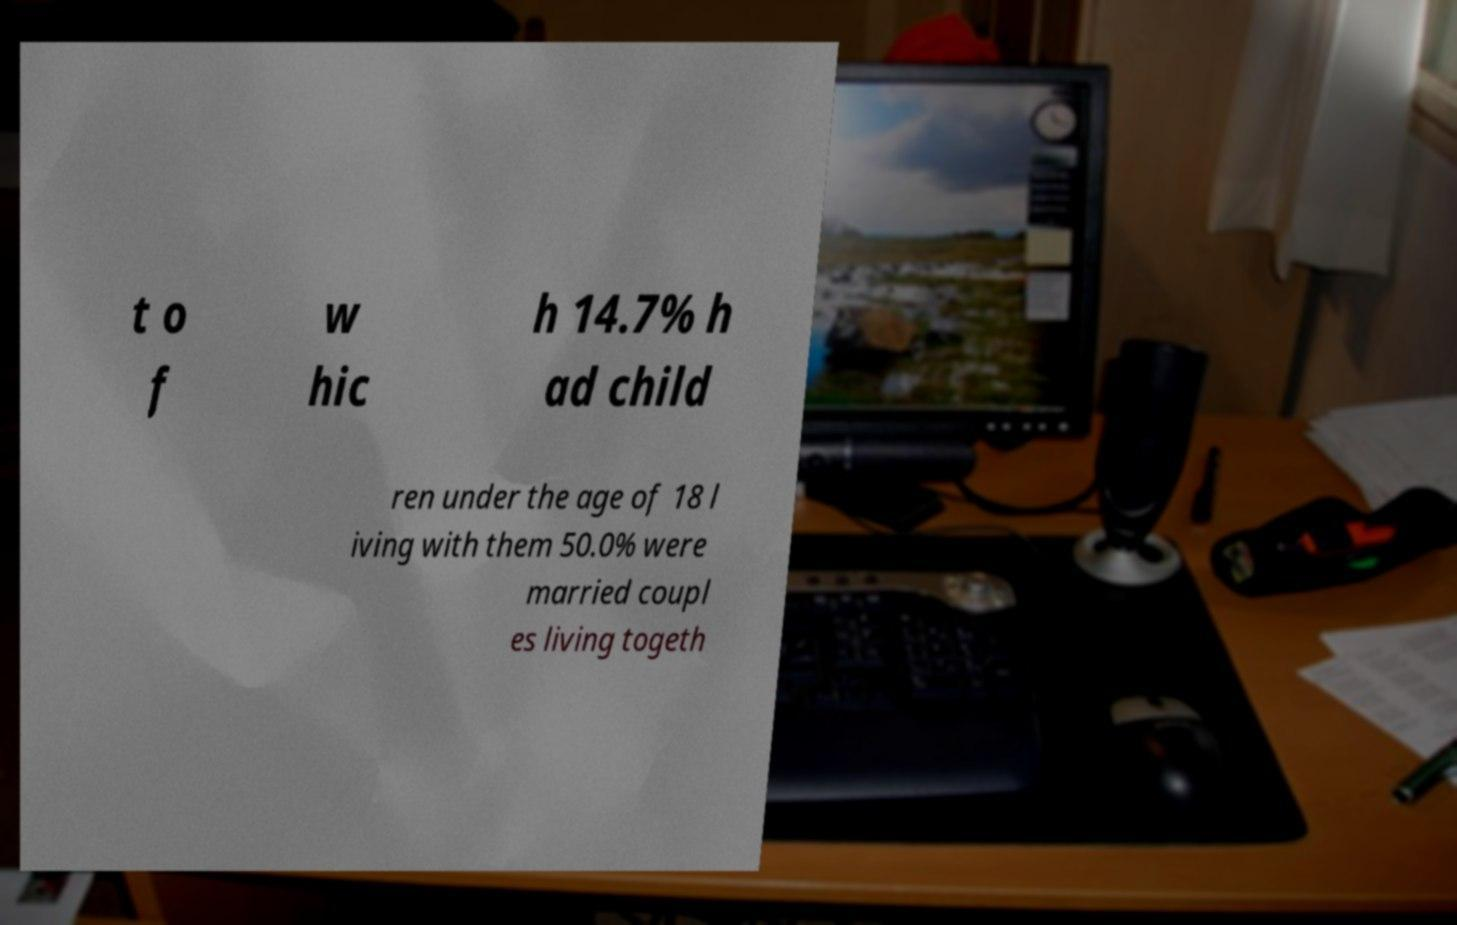Could you assist in decoding the text presented in this image and type it out clearly? t o f w hic h 14.7% h ad child ren under the age of 18 l iving with them 50.0% were married coupl es living togeth 